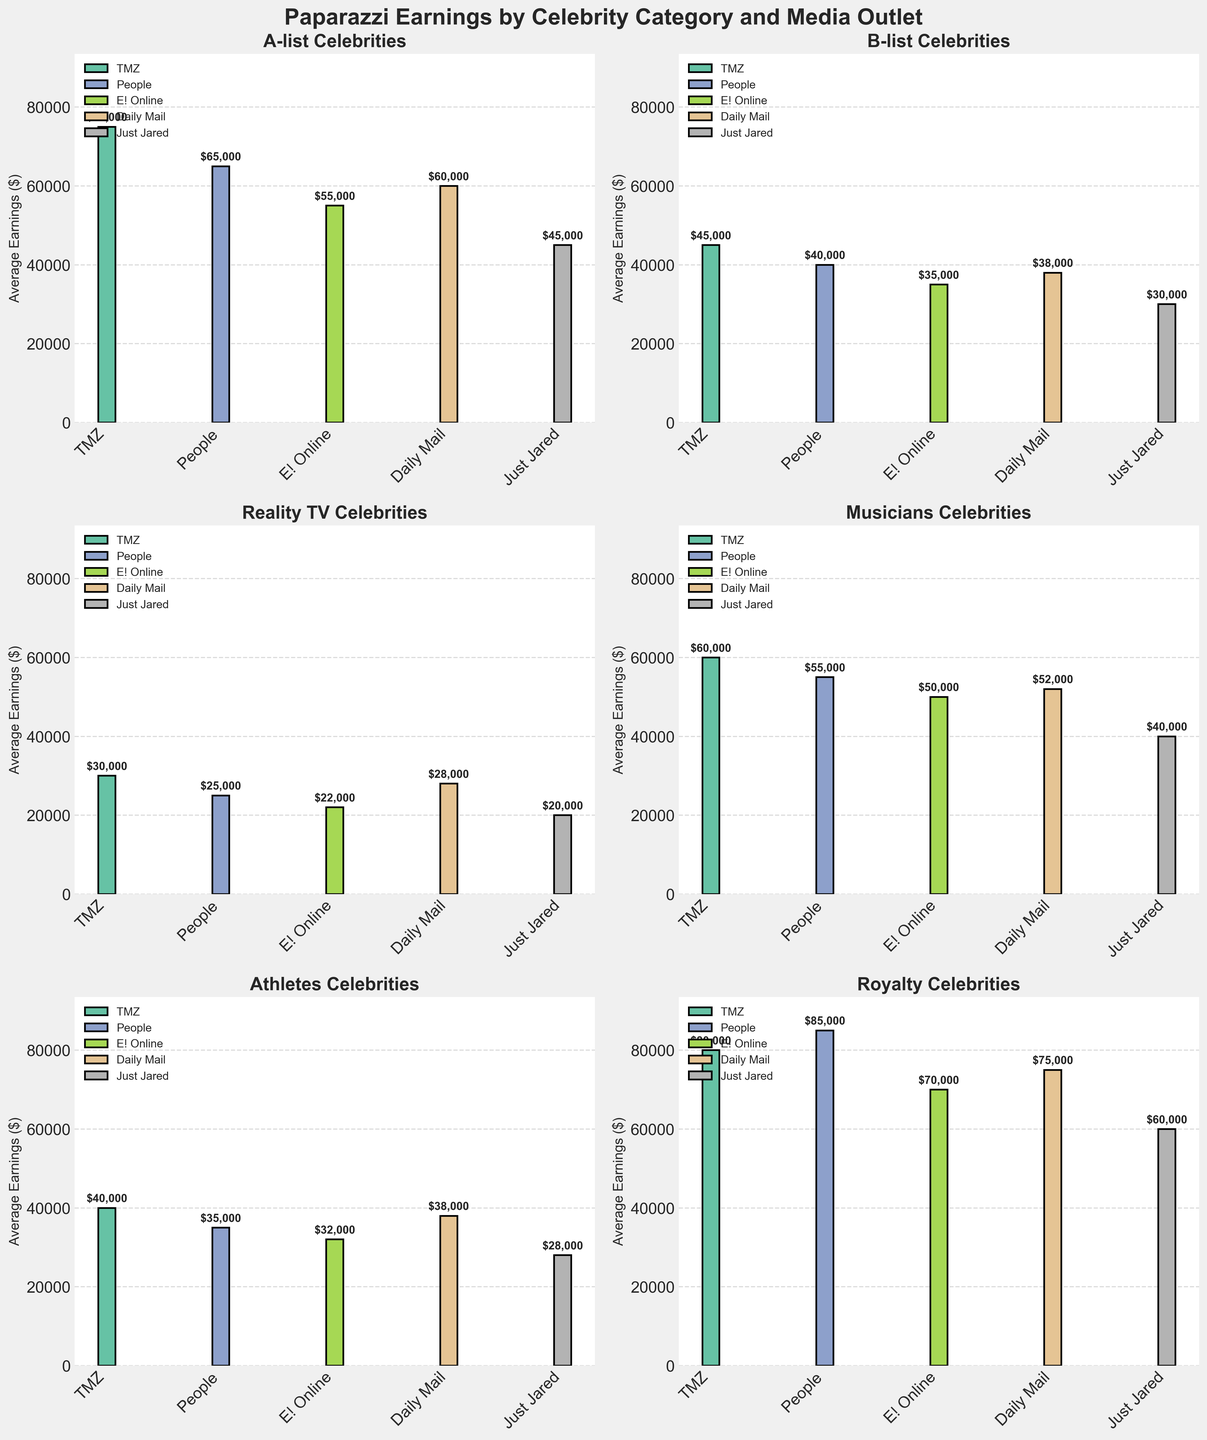Which celebrity category has the highest average earnings from TMZ? Look at the TMZ bars across all subplots and identify the tallest one. In this case, Royalty has the highest bar at TMZ, which indicates the highest average earnings.
Answer: Royalty Compare the average earnings from People for A-list celebrities and Musicians. Which category earns more? Find the bars for People within the A-list and Musicians subplots. The A-list bar is at $65,000 and the Musicians bar is at $55,000. $65,000 is greater than $55,000.
Answer: A-list Which media outlet pays the least for Reality TV celebrity photos? Identify the shortest bar within the Reality TV subplot. Just Jared has the shortest bar, indicating it pays the least.
Answer: Just Jared What is the difference in average earnings between the highest paying and lowest paying media outlet for Athletes? Look at the Athletes subplot, find the highest and lowest bars. TMZ pays $40,000 and Just Jared pays $28,000. Calculate the difference: $40,000 - $28,000 = $12,000
Answer: $12,000 Which media outlet shows the most consistent average earnings across all celebrity categories? Observe the height of the bars for each media outlet across all subplots. People appears to have fairly consistent bars across the categories.
Answer: People What is the average earning for Daily Mail across all celebrity categories? Sum the earnings for Daily Mail across all categories and divide by the number of categories. 60000 (A-list) + 38000 (B-list) + 28000 (Reality TV) + 52000 (Musicians) + 38000 (Athletes) + 75000 (Royalty) = 291000. Divide by 6 (number of categories), 291000 / 6 = 48500
Answer: $48,500 Which celebrity category shows the greatest earning disparity between media outlets? Identify the category with the largest difference between the highest and lowest bars within its subplot. Royalty ranges from $85,000 (People) to $60,000 (Just Jared), a difference of $25,000.
Answer: Royalty What is the total average earning from TMZ for A-list and B-list celebrities? Add the TMZ earnings for A-list and B-list celebrities. 75000 (A-list) + 45000 (B-list) = 120000
Answer: $120,000 